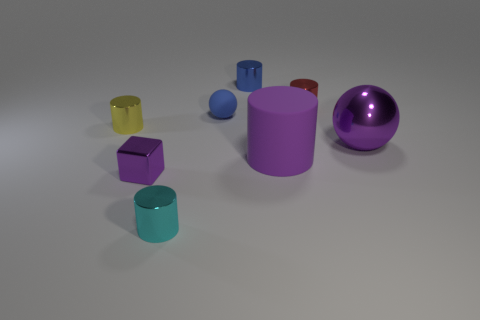Subtract all cyan cylinders. How many cylinders are left? 4 Subtract all purple cylinders. How many cylinders are left? 4 Subtract all gray cylinders. Subtract all cyan cubes. How many cylinders are left? 5 Add 2 small purple metallic blocks. How many objects exist? 10 Subtract all cubes. How many objects are left? 7 Add 1 large gray shiny cylinders. How many large gray shiny cylinders exist? 1 Subtract 0 green cylinders. How many objects are left? 8 Subtract all gray matte cylinders. Subtract all small metal cylinders. How many objects are left? 4 Add 2 large purple rubber objects. How many large purple rubber objects are left? 3 